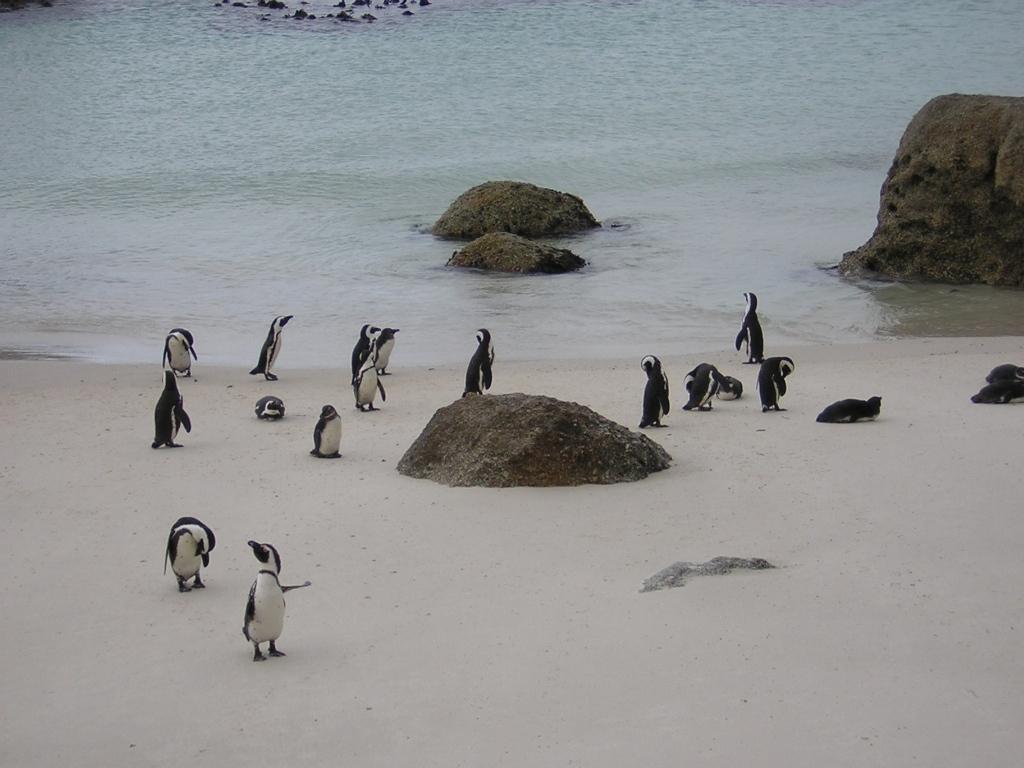Can you describe this image briefly? At the bottom of the image I can see penguins and rock. At the top of the image there is water and rocks. 